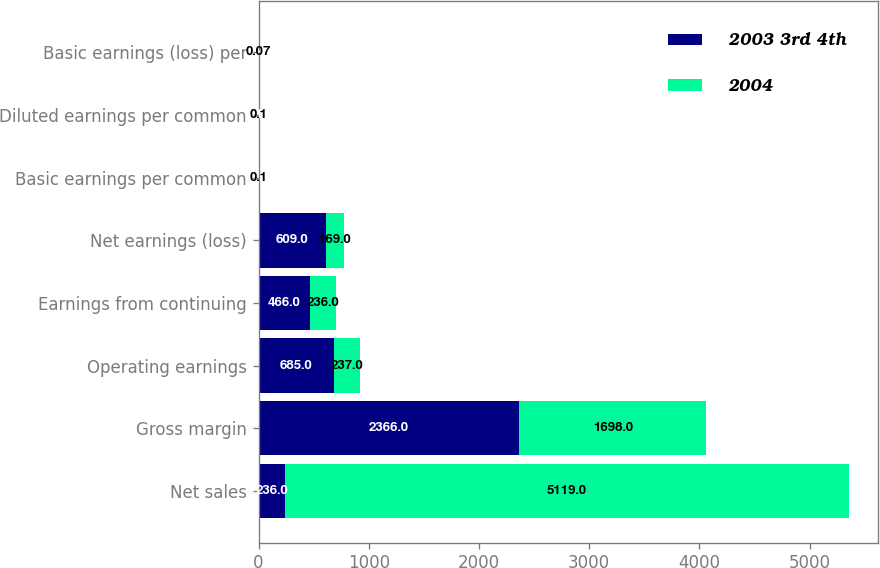Convert chart to OTSL. <chart><loc_0><loc_0><loc_500><loc_500><stacked_bar_chart><ecel><fcel>Net sales<fcel>Gross margin<fcel>Operating earnings<fcel>Earnings from continuing<fcel>Net earnings (loss)<fcel>Basic earnings per common<fcel>Diluted earnings per common<fcel>Basic earnings (loss) per<nl><fcel>2003 3rd 4th<fcel>236<fcel>2366<fcel>685<fcel>466<fcel>609<fcel>0.2<fcel>0.19<fcel>0.26<nl><fcel>2004<fcel>5119<fcel>1698<fcel>237<fcel>236<fcel>169<fcel>0.1<fcel>0.1<fcel>0.07<nl></chart> 